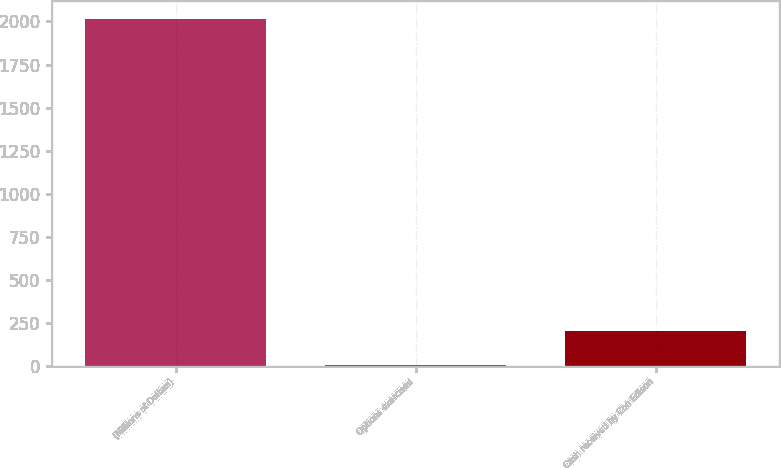Convert chart to OTSL. <chart><loc_0><loc_0><loc_500><loc_500><bar_chart><fcel>(Millions of Dollars)<fcel>Options exercised<fcel>Cash received by Con Edison<nl><fcel>2016<fcel>2<fcel>203.4<nl></chart> 